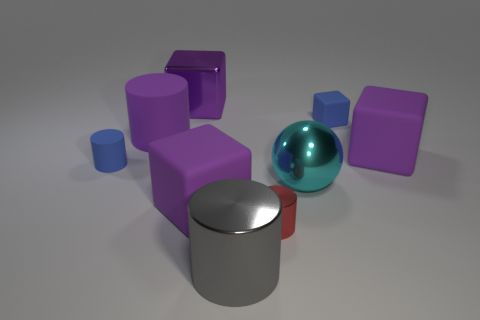The small matte thing that is the same shape as the large gray metallic object is what color?
Your answer should be very brief. Blue. Is the size of the blue matte cylinder the same as the red metallic thing?
Provide a short and direct response. Yes. Are there an equal number of tiny rubber blocks left of the small matte cylinder and purple objects that are to the right of the big gray cylinder?
Offer a terse response. No. Are any metal cubes visible?
Give a very brief answer. Yes. What size is the blue matte object that is the same shape as the red thing?
Offer a terse response. Small. There is a purple matte cube left of the gray shiny cylinder; how big is it?
Offer a very short reply. Large. Are there more big cyan shiny things left of the cyan object than small brown objects?
Provide a succinct answer. No. The small red thing has what shape?
Provide a succinct answer. Cylinder. There is a cube in front of the big metallic ball; is it the same color as the tiny rubber thing to the left of the small shiny thing?
Provide a short and direct response. No. Is the tiny metallic thing the same shape as the gray thing?
Offer a very short reply. Yes. 